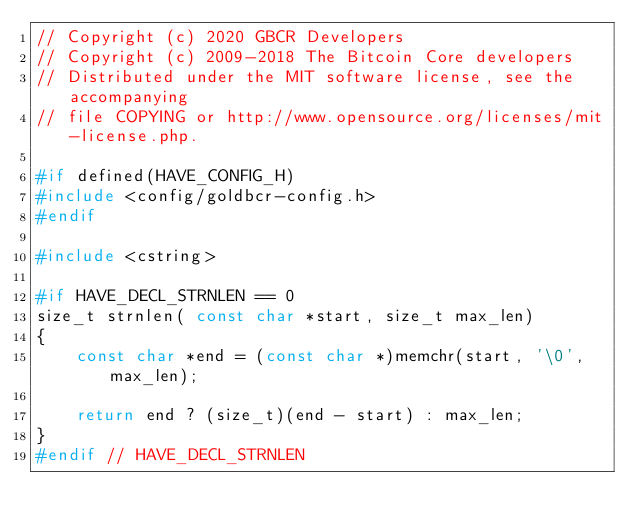Convert code to text. <code><loc_0><loc_0><loc_500><loc_500><_C++_>// Copyright (c) 2020 GBCR Developers
// Copyright (c) 2009-2018 The Bitcoin Core developers
// Distributed under the MIT software license, see the accompanying
// file COPYING or http://www.opensource.org/licenses/mit-license.php.

#if defined(HAVE_CONFIG_H)
#include <config/goldbcr-config.h>
#endif

#include <cstring>

#if HAVE_DECL_STRNLEN == 0
size_t strnlen( const char *start, size_t max_len)
{
    const char *end = (const char *)memchr(start, '\0', max_len);

    return end ? (size_t)(end - start) : max_len;
}
#endif // HAVE_DECL_STRNLEN
</code> 